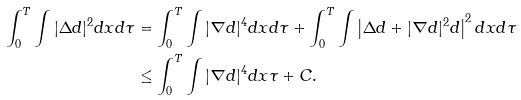Convert formula to latex. <formula><loc_0><loc_0><loc_500><loc_500>\int _ { 0 } ^ { T } \int | \Delta d | ^ { 2 } d x d \tau & = \int _ { 0 } ^ { T } \int | \nabla d | ^ { 4 } d x d \tau + \int _ { 0 } ^ { T } \int \left | \Delta d + | \nabla d | ^ { 2 } d \right | ^ { 2 } d x d \tau \\ & \leq \int _ { 0 } ^ { T } \int | \nabla d | ^ { 4 } d x \tau + C .</formula> 